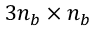<formula> <loc_0><loc_0><loc_500><loc_500>3 n _ { b } \times n _ { b }</formula> 